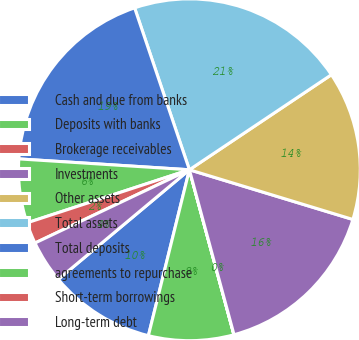Convert chart. <chart><loc_0><loc_0><loc_500><loc_500><pie_chart><fcel>Cash and due from banks<fcel>Deposits with banks<fcel>Brokerage receivables<fcel>Investments<fcel>Other assets<fcel>Total assets<fcel>Total deposits<fcel>agreements to repurchase<fcel>Short-term borrowings<fcel>Long-term debt<nl><fcel>10.06%<fcel>8.05%<fcel>0.01%<fcel>16.09%<fcel>14.08%<fcel>20.8%<fcel>18.79%<fcel>6.04%<fcel>2.02%<fcel>4.03%<nl></chart> 